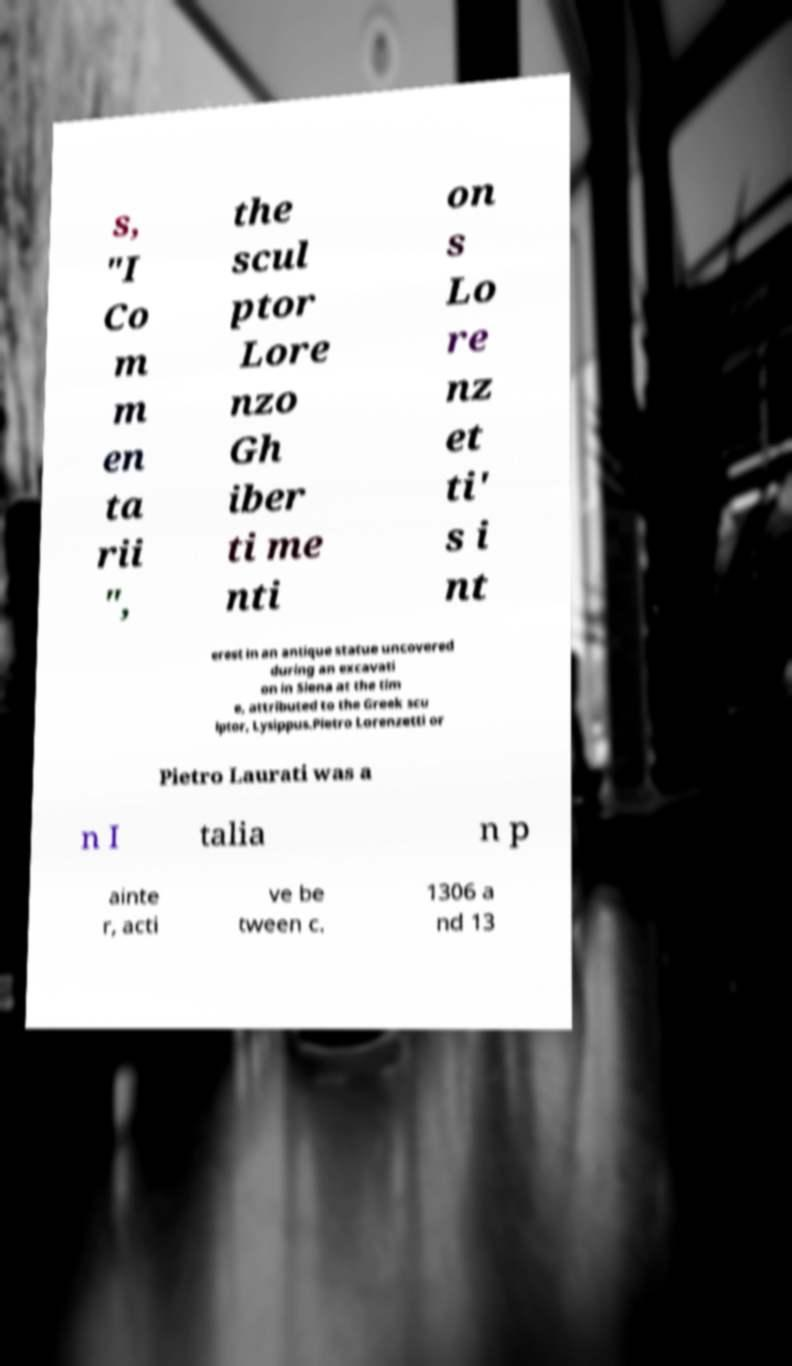What messages or text are displayed in this image? I need them in a readable, typed format. s, "I Co m m en ta rii ", the scul ptor Lore nzo Gh iber ti me nti on s Lo re nz et ti' s i nt erest in an antique statue uncovered during an excavati on in Siena at the tim e, attributed to the Greek scu lptor, Lysippus.Pietro Lorenzetti or Pietro Laurati was a n I talia n p ainte r, acti ve be tween c. 1306 a nd 13 